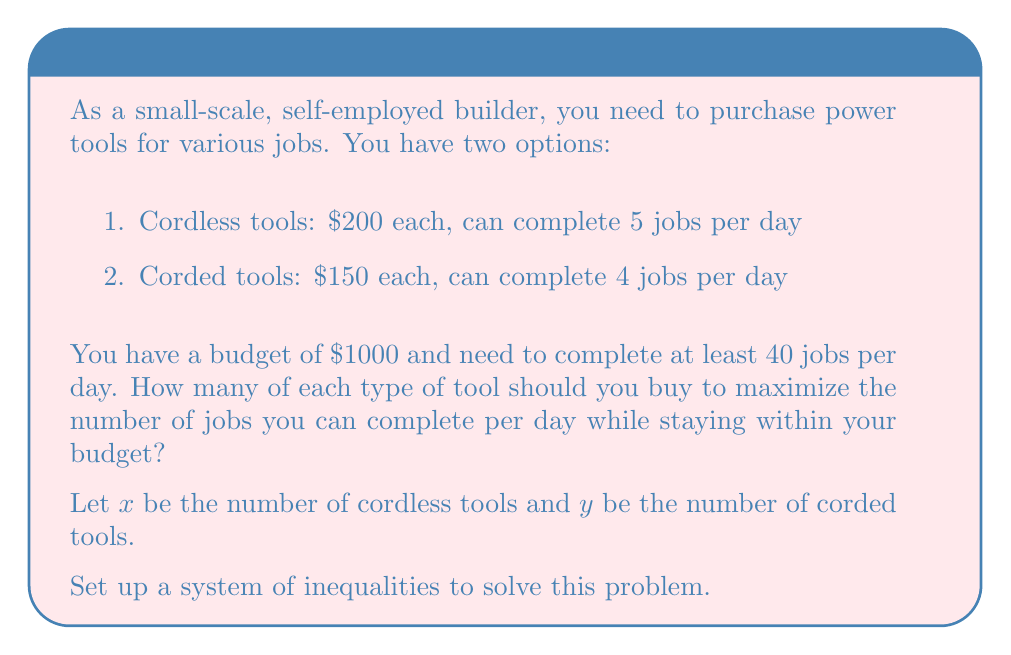Can you solve this math problem? Let's approach this step-by-step:

1. Set up the budget constraint:
   $$200x + 150y \leq 1000$$

2. Set up the minimum jobs constraint:
   $$5x + 4y \geq 40$$

3. Non-negativity constraints:
   $$x \geq 0, y \geq 0$$

4. We want to maximize the number of jobs completed per day:
   $$\text{Maximize: } 5x + 4y$$

5. Graph the inequalities:
   [asy]
   import graph;
   size(200);
   xaxis("Cordless tools (x)", 0, 6, Arrow);
   yaxis("Corded tools (y)", 0, 8, Arrow);
   draw((0,6.67)--(5,0), blue);
   draw((0,10)--(8,0), red);
   fill((0,6.67)--(4,2.5)--(5,0)--(0,0)--cycle, palegreen);
   label("Budget constraint", (2.5,3.33), blue);
   label("Jobs constraint", (4,5), red);
   label("Feasible region", (2,2), green);
   [/asy]

6. Find the intersection points:
   - (0, 6.67) and (5, 0) for the budget constraint
   - (0, 10) and (8, 0) for the jobs constraint
   - The feasible region is the area bounded by these lines and the axes

7. Check the corner points of the feasible region:
   - (0, 6): 0(5) + 6(4) = 24 jobs
   - (4, 2): 4(5) + 2(4) = 28 jobs
   - (5, 0): 5(5) + 0(4) = 25 jobs

8. The maximum number of jobs is achieved at (4, 2)

Therefore, you should buy 4 cordless tools and 2 corded tools to maximize the number of jobs completed per day (28) while staying within your budget.
Answer: Buy 4 cordless tools and 2 corded tools. 